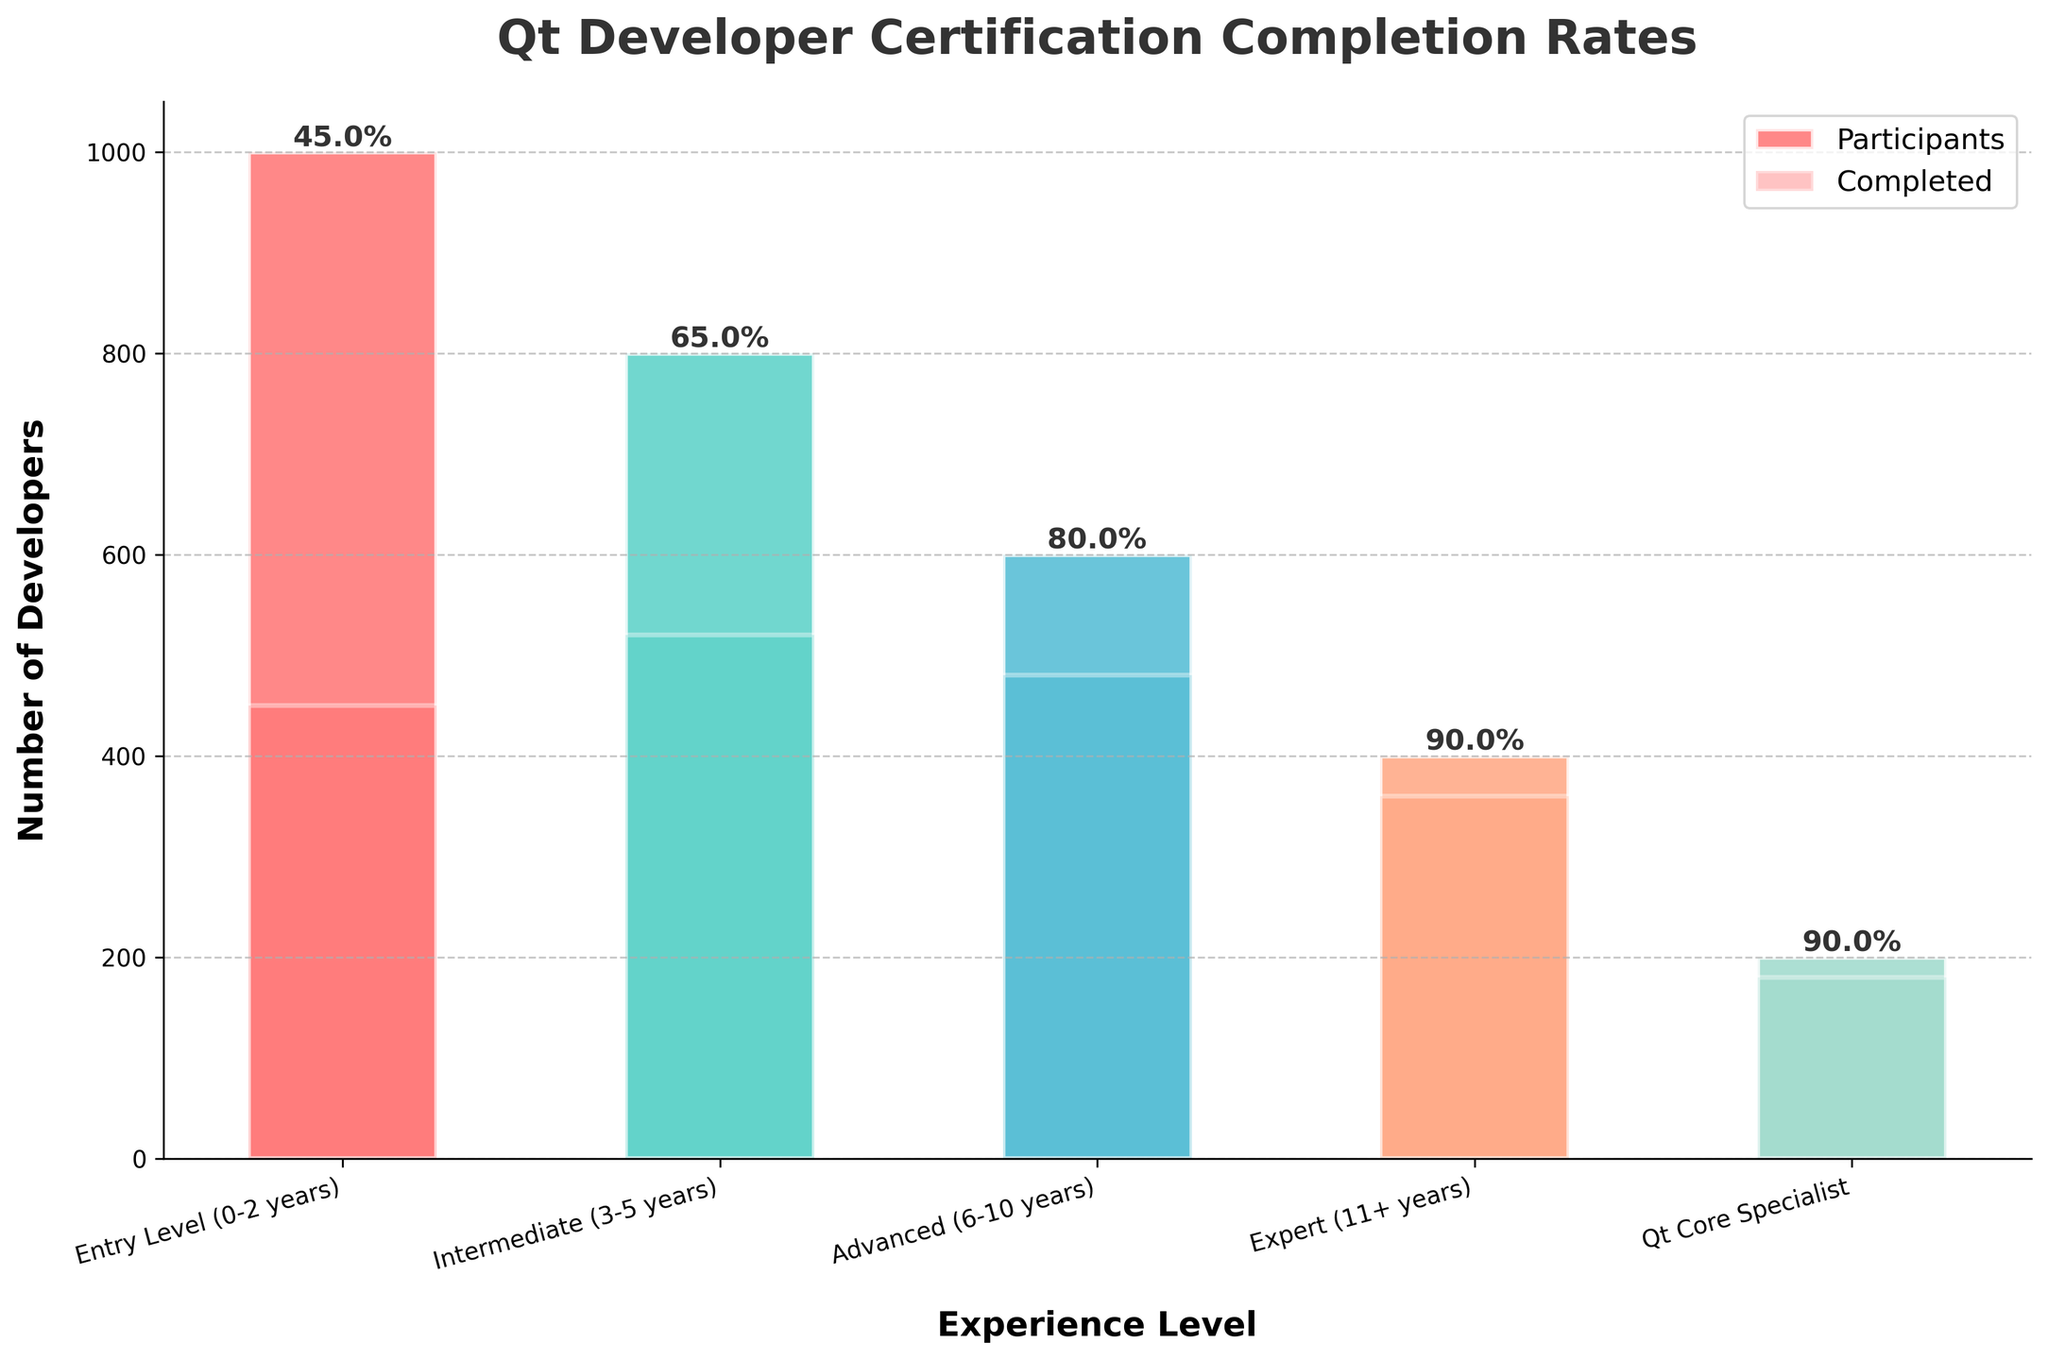what is the highest percentage completion rate among the experience levels? From the funnel chart, examine the percentage labels, determine the highest completion rate by comparing the values: Entry Level (45%), Intermediate (65%), Advanced (80%), Expert (90%), Core Specialist (90%), Core Specialist or Expert has the highest
Answer: 90% Which experience level has the most participants? Check the tallest bars (representing participants) on the funnel chart for each experience level. Entry Level has the highest bar (1000).
Answer: Entry Level What's the completion rate percentage for Intermediate level developers? Look next to the Intermediate level and note the percentage label indicating the completion rate (Intermediate: 65%)
Answer: 65% What's the total number of participants in the Advanced and Expert levels together? Sum the participant numbers for Advanced (600) and Expert (400) levels: 600 + 400 = 1000
Answer: 1000 By how much does the number of participants at the Entry Level exceed the number at the Qt Core Specialist level? Calculate the difference between Entry Level (1000) and Qt Core Specialist (200): 1000 - 200 = 800
Answer: 800 Which experience level has the smallest completion rate? Examine the percentage labels for all experience levels, Entry Level has the smallest percentage (45%)
Answer: Entry Level How many more developers completed the certification at the Intermediate level than at the Entry Level? Subtract the number of completed certifications for Entry Level (450) from Intermediate (520): 520 - 450 = 70
Answer: 70 What's the combined completion rate for Advanced and Expert levels? Sum the completed certification numbers for Advanced (480) and Expert (360): 480 + 360 = 840
Answer: 840 Which experience level category has the highest completion rate visually represented by the lightest-colored bar? The lightest-colored bars in the chart represent the completion, Highest completion rates are Expert and Qt Core Specialist, both at 90%
Answer: Expert and Qt Core Specialist 